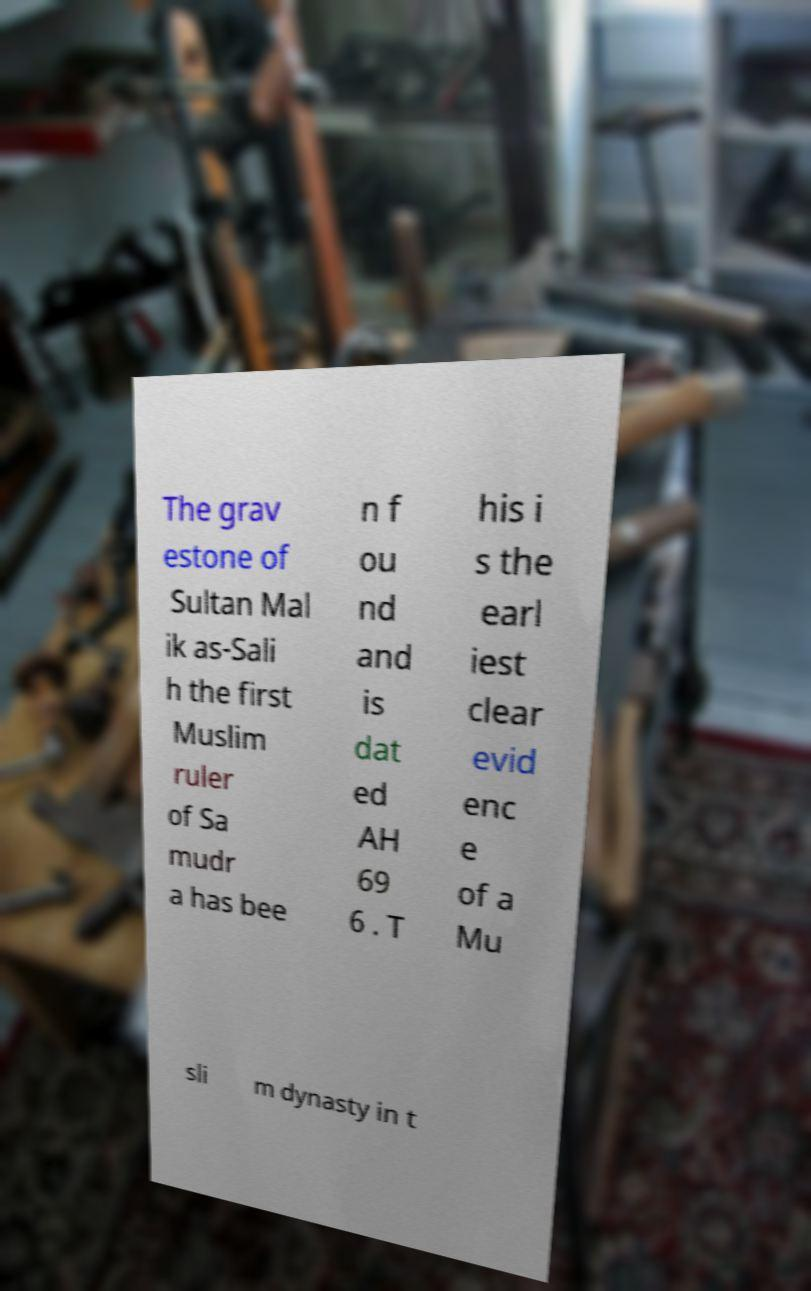Please identify and transcribe the text found in this image. The grav estone of Sultan Mal ik as-Sali h the first Muslim ruler of Sa mudr a has bee n f ou nd and is dat ed AH 69 6 . T his i s the earl iest clear evid enc e of a Mu sli m dynasty in t 